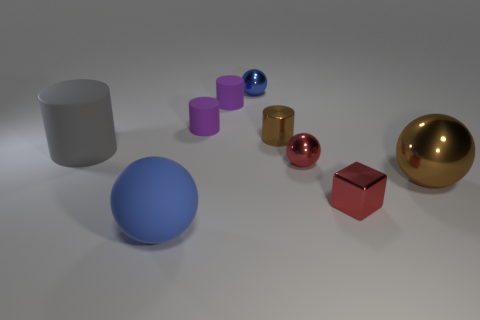Add 1 tiny brown objects. How many objects exist? 10 Subtract all blocks. How many objects are left? 8 Add 3 tiny red cylinders. How many tiny red cylinders exist? 3 Subtract 1 gray cylinders. How many objects are left? 8 Subtract all purple rubber cylinders. Subtract all gray matte cylinders. How many objects are left? 6 Add 5 tiny blue objects. How many tiny blue objects are left? 6 